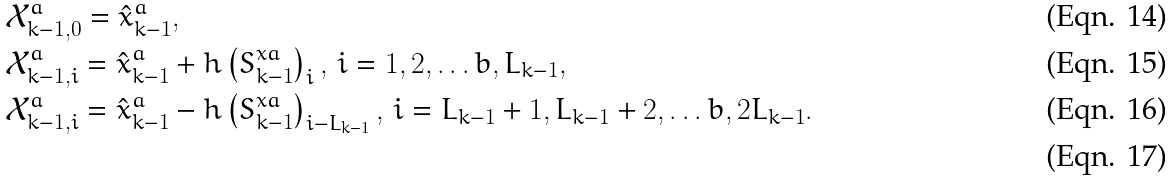Convert formula to latex. <formula><loc_0><loc_0><loc_500><loc_500>& \mathcal { X } _ { k - 1 , 0 } ^ { a } = \hat { x } ^ { a } _ { k - 1 } , \\ & \mathcal { X } _ { k - 1 , i } ^ { a } = \hat { x } ^ { a } _ { k - 1 } + h \left ( S ^ { x a } _ { k - 1 } \right ) _ { i } , \, i = 1 , 2 , \dots b , L _ { k - 1 } , \\ & \mathcal { X } _ { k - 1 , i } ^ { a } = \hat { x } ^ { a } _ { k - 1 } - h \left ( S ^ { x a } _ { k - 1 } \right ) _ { i - L _ { k - 1 } } , \, i = L _ { k - 1 } + 1 , L _ { k - 1 } + 2 , \dots b , 2 L _ { k - 1 } . \\</formula> 